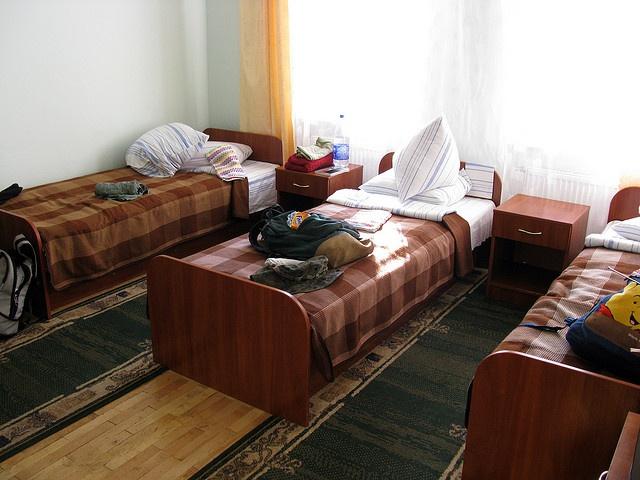Describe the objects in this image and their specific colors. I can see bed in lightgray, black, maroon, white, and brown tones, bed in lightgray, black, maroon, brown, and darkgray tones, bed in lightgray, maroon, black, and darkgray tones, backpack in lightgray, black, olive, and maroon tones, and backpack in lightgray, black, maroon, and gray tones in this image. 